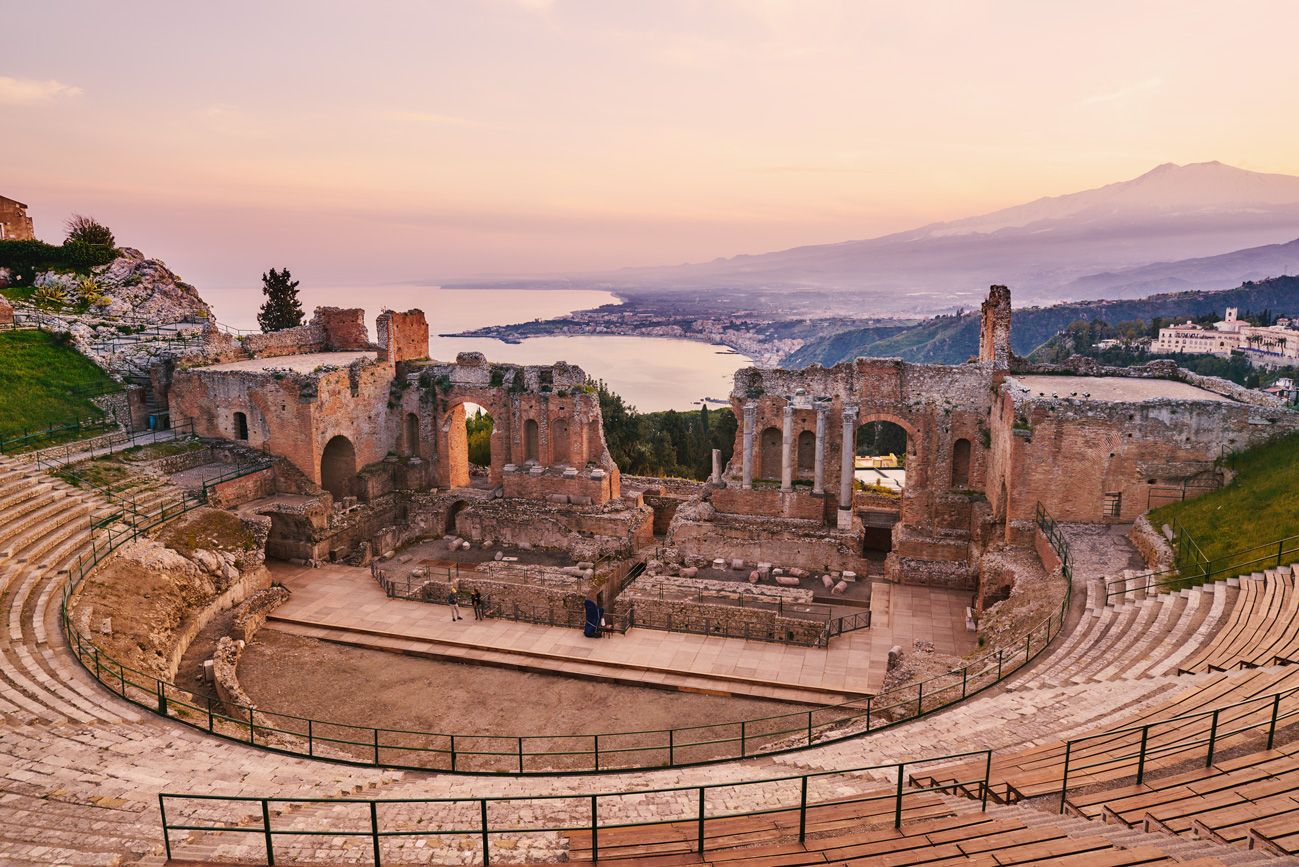Can you tell me more about the architectural style of this theater? Certainly! The Greek Theater of Taormina exhibits the classic features of Hellenistic architectural design, which includes a large orchestra (the playing area) and a cavea (tiered seating). The theaterís acoustics and the integration with the natural landscape, allowing spectators to view both the performances and the scenic backdrop of the sea and Mount Etna, demonstrate the Greeks' mastery in creating functional and aesthetic spaces. 